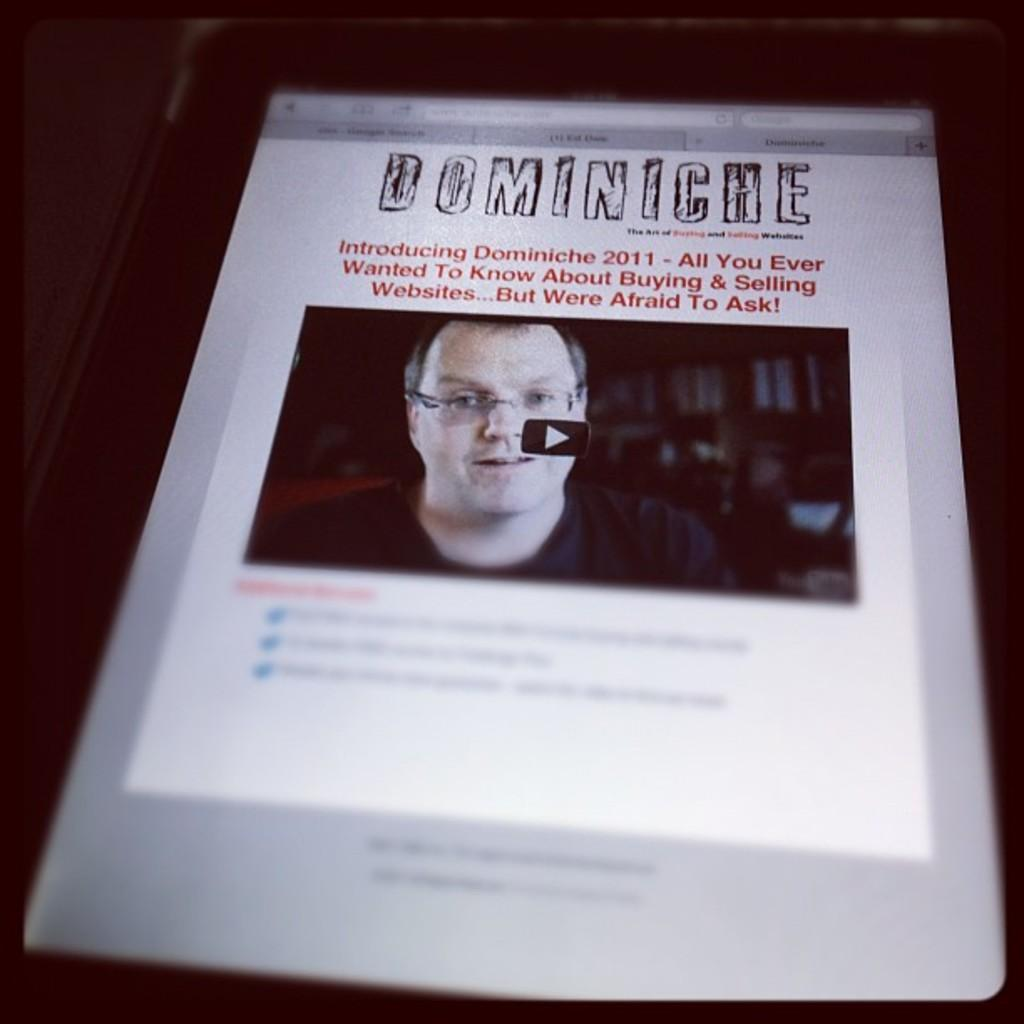What is the main subject of the image? There is a person's face in the image. What is visible on the screen in the image? There is something on a screen in the image, which appears to be an electronic device. What is the color of the background in the image? The background of the image is black. How many lines can be seen on the person's face in the image? There are no lines visible on the person's face in the image. What type of health advice is being given on the screen in the image? There is no health advice present in the image; it only shows an electronic device on the screen. 